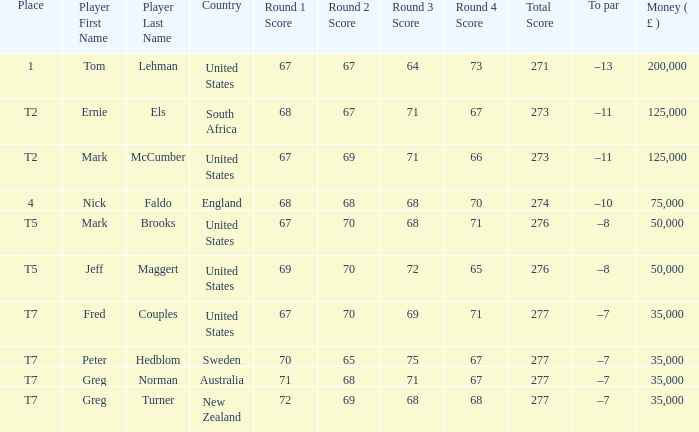What is Score, when Money ( £ ) is greater than 35,000, and when Country is "United States"? 67-67-64-73=271, 67-69-71-66=273, 67-70-68-71=276, 69-70-72-65=276. 